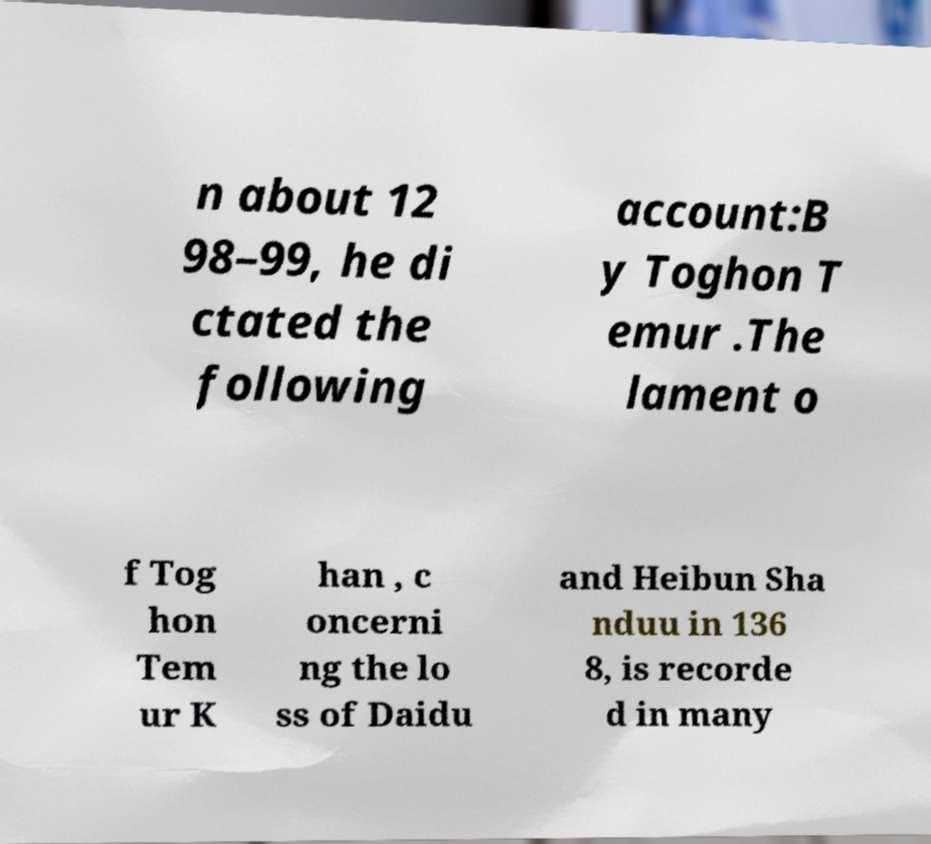What messages or text are displayed in this image? I need them in a readable, typed format. n about 12 98–99, he di ctated the following account:B y Toghon T emur .The lament o f Tog hon Tem ur K han , c oncerni ng the lo ss of Daidu and Heibun Sha nduu in 136 8, is recorde d in many 